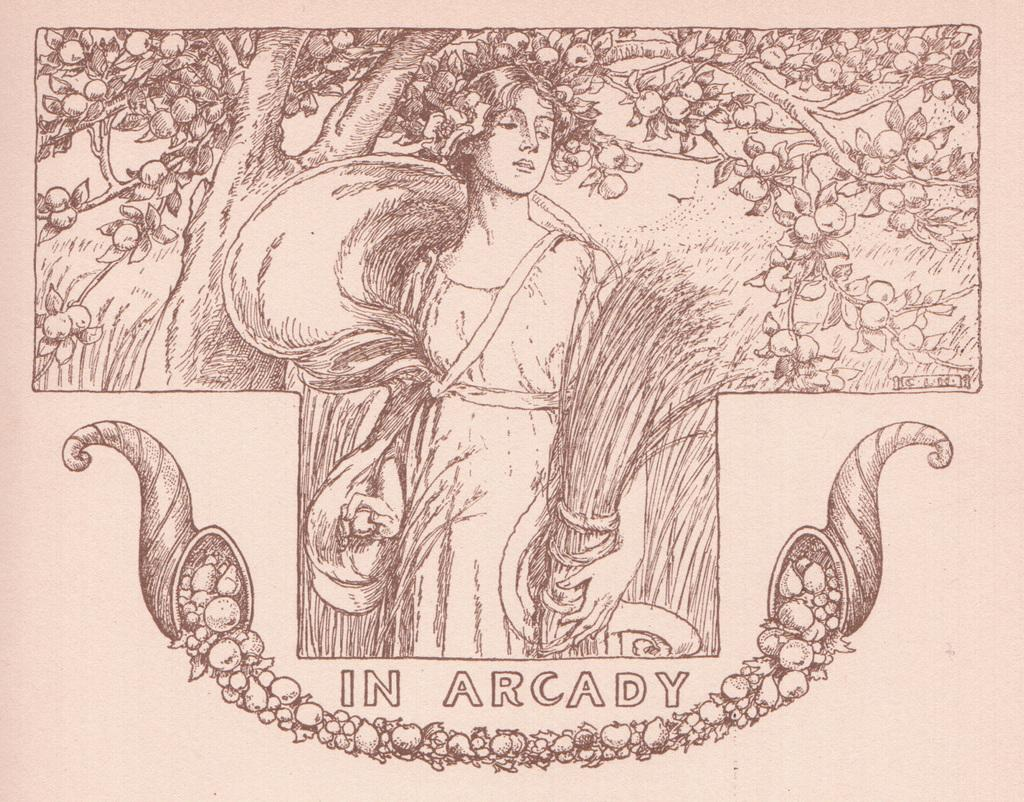What is depicted in the drawing in the image? There is a drawing of a lady in the image. What other elements can be seen in the image besides the drawing? There is a tree and writing in the image. What type of honey is being collected by the duck in the image? There is no duck or honey present in the image; it features a drawing of a lady, a tree, and writing. 